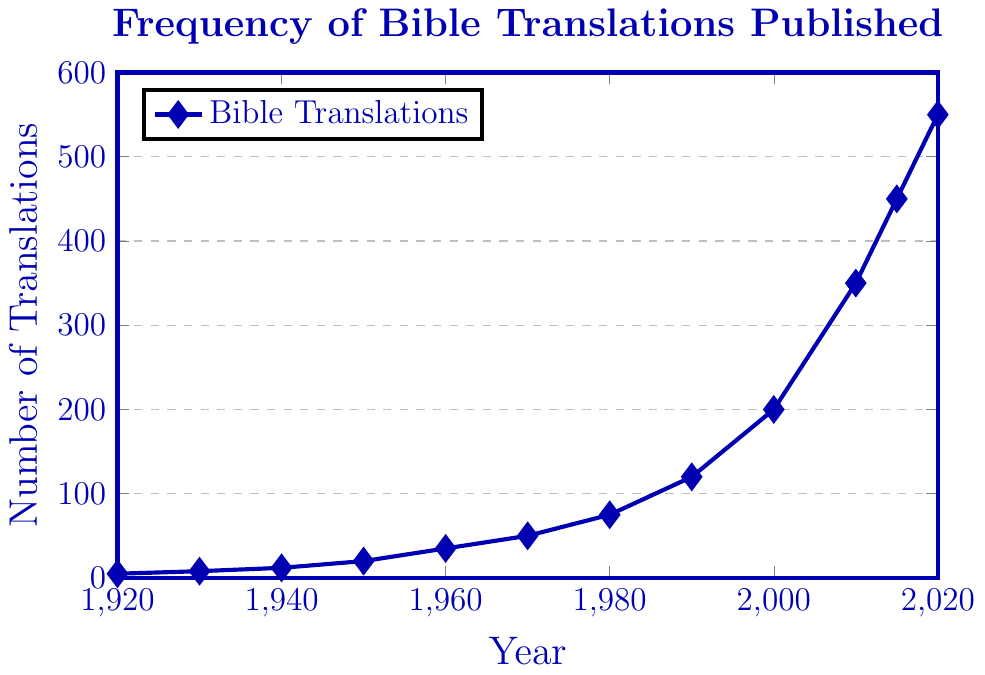What year saw the largest increase in the number of Bible translations published compared to the previous decade? To find the year with the largest increase, calculate the difference in the number of translations between each pair of decades: 1920-1930 (3), 1930-1940 (4), 1940-1950 (8), 1950-1960 (15), 1960-1970 (15), 1970-1980 (25), 1980-1990 (45), 1990-2000 (80), 2000-2010 (150), 2010-2015 (100), 2015-2020 (100). The largest increase is 150 (from 2000 to 2010).
Answer: 2000 to 2010 How did the number of Bible translations published change from 1960 to 2010? First, find the values for 1960 and 2010, which are 35 and 350, respectively. Then, calculate the difference: 350 - 35 = 315. From 1960 to 2010, the number increased by 315.
Answer: Increased by 315 Was there a period when the number of Bible translations published doubled in less than a decade? Look for periods where the number doubled: from 200 to 350 between 2000 and 2010, and from 8 to 20 between 1930 and 1950. Both of these periods show a doubling in translations within a decade. Yes, it doubled between 2000-2010 and 1930-1950.
Answer: Yes What is the average number of Bible translations published per decade from 1920 to 2020? Sum the total number of translations for all decades: 5 + 8 + 12 + 20 + 35 + 50 + 75 + 120 + 200 + 350 + 450 + 550 = 1875. There are 11 decades between 1920 and 2020, so the average is 1875 / 11 ≈ 170.45.
Answer: 170.45 Which decade experienced the least growth in the number of Bible translations published? Calculate the difference for each decade: 1920-1930 (3), 1930-1940 (4), 1940-1950 (8), 1950-1960 (15), 1960-1970 (15), 1970-1980 (25), 1980-1990 (45), 1990-2000 (80), 2000-2010 (150), 2010-2015 (100), 2015-2020 (100). The smallest growth is from 1930 to 1940 (4).
Answer: 1930 to 1940 How many more Bible translations were published in 2020 compared to 1980? Look up the values for 2020 (550) and 1980 (75), then calculate the difference: 550 - 75 = 475. So, there were 475 more translations published in 2020 than in 1980.
Answer: 475 In what year did the number of Bible translations first exceed 100? Find the first data point where the number exceeds 100. The value is 120 in 1990; before 1990, in 1980, it was 75. Therefore, 1990 is the first year the number exceeded 100.
Answer: 1990 